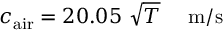<formula> <loc_0><loc_0><loc_500><loc_500>c _ { a i r } = 2 0 . 0 5 { \sqrt { T } } m / s</formula> 